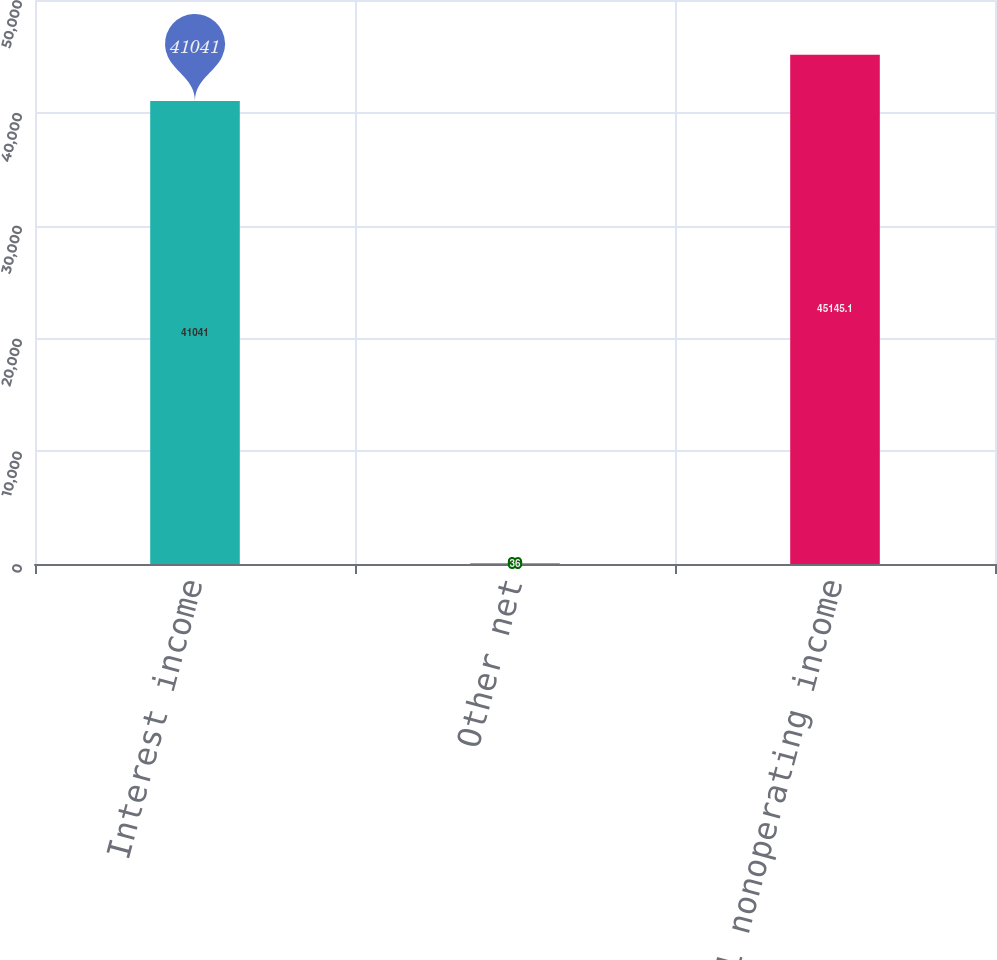Convert chart to OTSL. <chart><loc_0><loc_0><loc_500><loc_500><bar_chart><fcel>Interest income<fcel>Other net<fcel>Total nonoperating income<nl><fcel>41041<fcel>36<fcel>45145.1<nl></chart> 